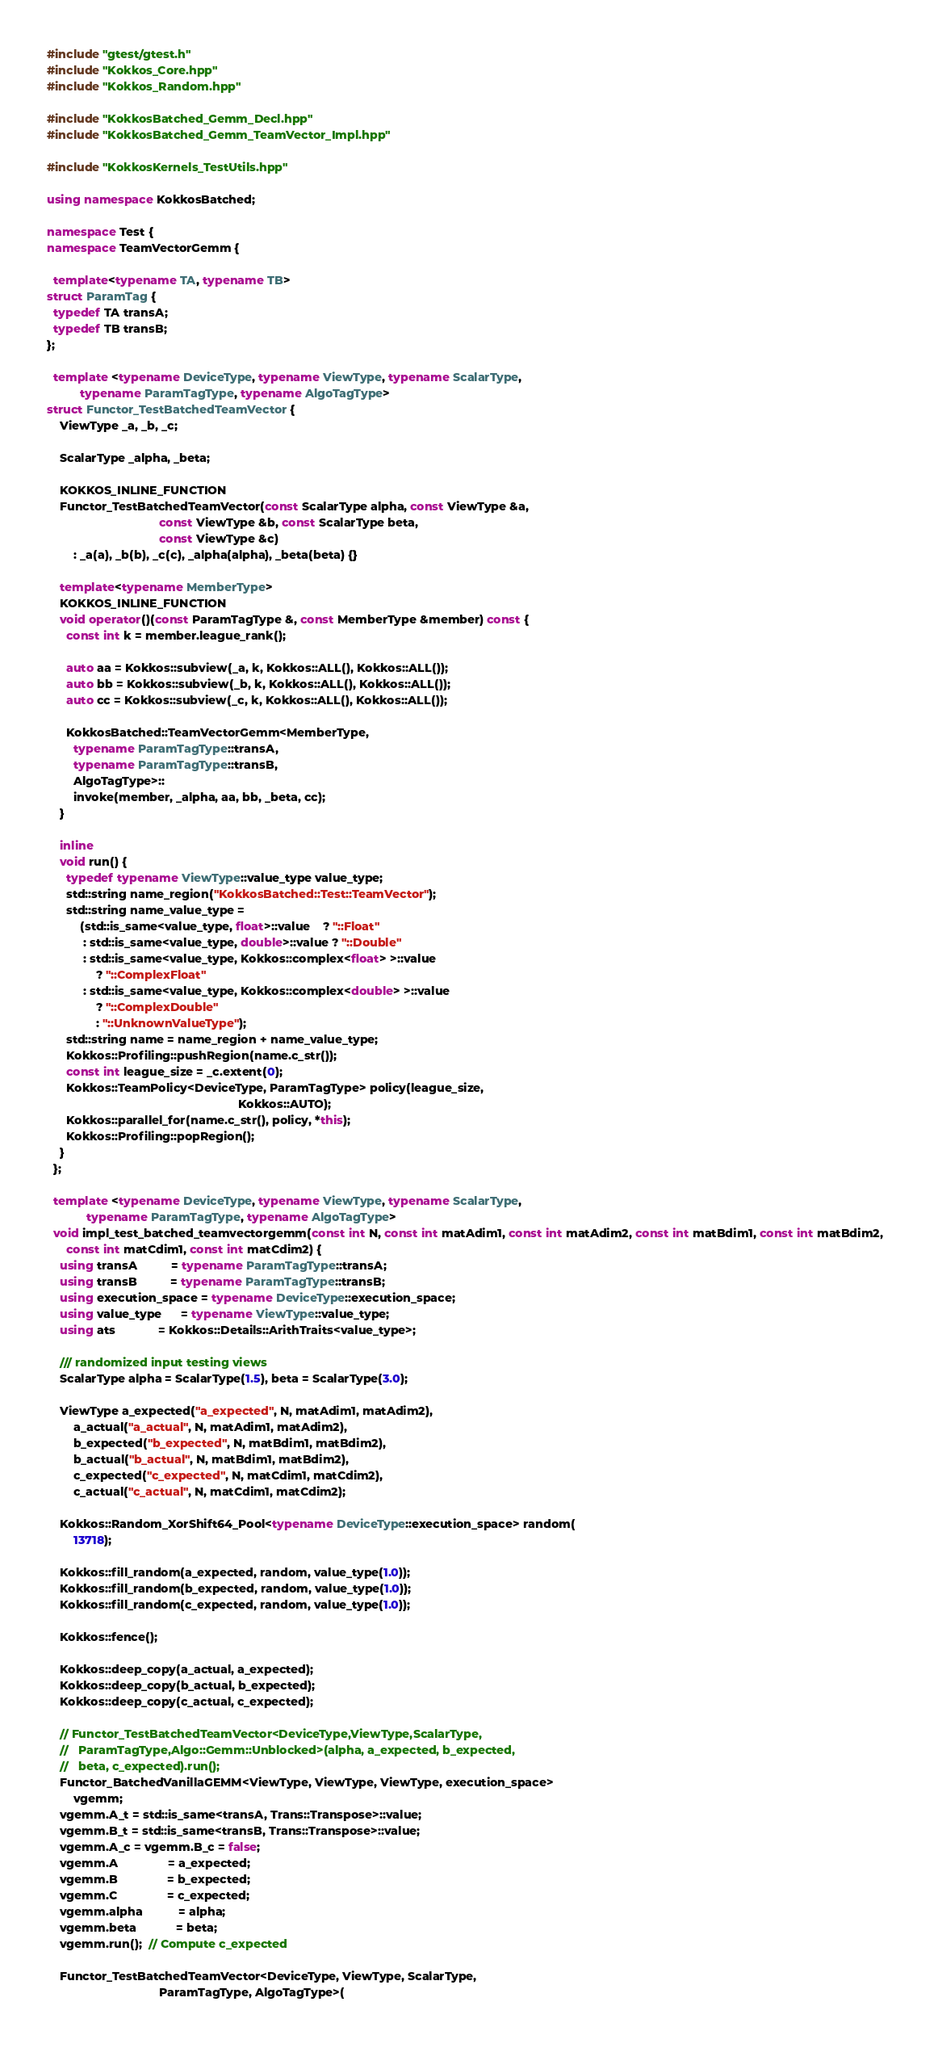Convert code to text. <code><loc_0><loc_0><loc_500><loc_500><_C++_>#include "gtest/gtest.h"
#include "Kokkos_Core.hpp"
#include "Kokkos_Random.hpp"

#include "KokkosBatched_Gemm_Decl.hpp"
#include "KokkosBatched_Gemm_TeamVector_Impl.hpp"

#include "KokkosKernels_TestUtils.hpp"

using namespace KokkosBatched;

namespace Test {
namespace TeamVectorGemm {

  template<typename TA, typename TB>
struct ParamTag {
  typedef TA transA;
  typedef TB transB;
};

  template <typename DeviceType, typename ViewType, typename ScalarType,
          typename ParamTagType, typename AlgoTagType>
struct Functor_TestBatchedTeamVector {
    ViewType _a, _b, _c;

    ScalarType _alpha, _beta;

    KOKKOS_INLINE_FUNCTION
    Functor_TestBatchedTeamVector(const ScalarType alpha, const ViewType &a,
                                  const ViewType &b, const ScalarType beta,
                                  const ViewType &c)
        : _a(a), _b(b), _c(c), _alpha(alpha), _beta(beta) {}

    template<typename MemberType>
    KOKKOS_INLINE_FUNCTION
    void operator()(const ParamTagType &, const MemberType &member) const {
      const int k = member.league_rank();

      auto aa = Kokkos::subview(_a, k, Kokkos::ALL(), Kokkos::ALL());
      auto bb = Kokkos::subview(_b, k, Kokkos::ALL(), Kokkos::ALL());
      auto cc = Kokkos::subview(_c, k, Kokkos::ALL(), Kokkos::ALL());

      KokkosBatched::TeamVectorGemm<MemberType,
        typename ParamTagType::transA,
        typename ParamTagType::transB,
        AlgoTagType>::
        invoke(member, _alpha, aa, bb, _beta, cc);
    }

    inline
    void run() {
      typedef typename ViewType::value_type value_type;
      std::string name_region("KokkosBatched::Test::TeamVector");
      std::string name_value_type =
          (std::is_same<value_type, float>::value    ? "::Float"
           : std::is_same<value_type, double>::value ? "::Double"
           : std::is_same<value_type, Kokkos::complex<float> >::value
               ? "::ComplexFloat"
           : std::is_same<value_type, Kokkos::complex<double> >::value
               ? "::ComplexDouble"
               : "::UnknownValueType");
      std::string name = name_region + name_value_type;
      Kokkos::Profiling::pushRegion(name.c_str());
      const int league_size = _c.extent(0);
      Kokkos::TeamPolicy<DeviceType, ParamTagType> policy(league_size,
                                                          Kokkos::AUTO);
      Kokkos::parallel_for(name.c_str(), policy, *this);
      Kokkos::Profiling::popRegion();
    }
  };

  template <typename DeviceType, typename ViewType, typename ScalarType,
            typename ParamTagType, typename AlgoTagType>
  void impl_test_batched_teamvectorgemm(const int N, const int matAdim1, const int matAdim2, const int matBdim1, const int matBdim2,
      const int matCdim1, const int matCdim2) {
    using transA          = typename ParamTagType::transA;
    using transB          = typename ParamTagType::transB;
    using execution_space = typename DeviceType::execution_space;
    using value_type      = typename ViewType::value_type;
    using ats             = Kokkos::Details::ArithTraits<value_type>;

    /// randomized input testing views
    ScalarType alpha = ScalarType(1.5), beta = ScalarType(3.0);

    ViewType a_expected("a_expected", N, matAdim1, matAdim2),
        a_actual("a_actual", N, matAdim1, matAdim2),
        b_expected("b_expected", N, matBdim1, matBdim2),
        b_actual("b_actual", N, matBdim1, matBdim2),
        c_expected("c_expected", N, matCdim1, matCdim2),
        c_actual("c_actual", N, matCdim1, matCdim2);

    Kokkos::Random_XorShift64_Pool<typename DeviceType::execution_space> random(
        13718);

    Kokkos::fill_random(a_expected, random, value_type(1.0));
    Kokkos::fill_random(b_expected, random, value_type(1.0));
    Kokkos::fill_random(c_expected, random, value_type(1.0));

    Kokkos::fence();

    Kokkos::deep_copy(a_actual, a_expected);
    Kokkos::deep_copy(b_actual, b_expected);
    Kokkos::deep_copy(c_actual, c_expected);

    // Functor_TestBatchedTeamVector<DeviceType,ViewType,ScalarType,
    //   ParamTagType,Algo::Gemm::Unblocked>(alpha, a_expected, b_expected,
    //   beta, c_expected).run();
    Functor_BatchedVanillaGEMM<ViewType, ViewType, ViewType, execution_space>
        vgemm;
    vgemm.A_t = std::is_same<transA, Trans::Transpose>::value;
    vgemm.B_t = std::is_same<transB, Trans::Transpose>::value;
    vgemm.A_c = vgemm.B_c = false;
    vgemm.A               = a_expected;
    vgemm.B               = b_expected;
    vgemm.C               = c_expected;
    vgemm.alpha           = alpha;
    vgemm.beta            = beta;
    vgemm.run();  // Compute c_expected

    Functor_TestBatchedTeamVector<DeviceType, ViewType, ScalarType,
                                  ParamTagType, AlgoTagType>(</code> 